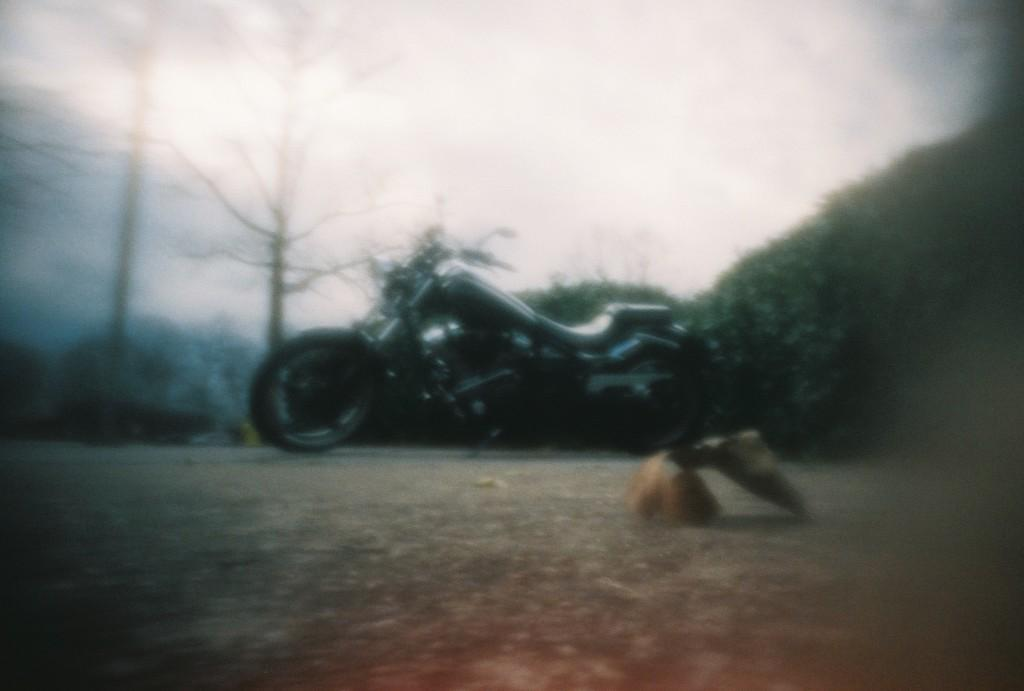What is the main subject of the image? The main subject of the image is a motorbike. Where is the motorbike located in the image? The motorbike is on the road in the image. What can be seen in the background of the image? There are trees in the background of the image. What type of throne is visible in the image? There is no throne present in the image; it features a motorbike on the road with trees in the background. 